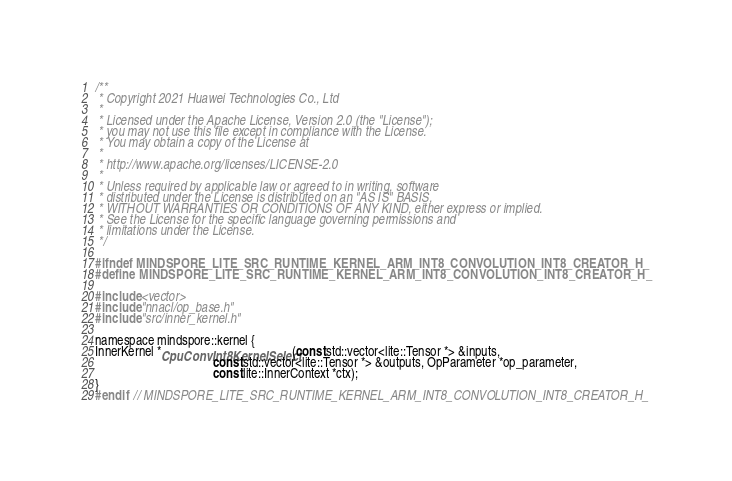Convert code to text. <code><loc_0><loc_0><loc_500><loc_500><_C_>/**
 * Copyright 2021 Huawei Technologies Co., Ltd
 *
 * Licensed under the Apache License, Version 2.0 (the "License");
 * you may not use this file except in compliance with the License.
 * You may obtain a copy of the License at
 *
 * http://www.apache.org/licenses/LICENSE-2.0
 *
 * Unless required by applicable law or agreed to in writing, software
 * distributed under the License is distributed on an "AS IS" BASIS,
 * WITHOUT WARRANTIES OR CONDITIONS OF ANY KIND, either express or implied.
 * See the License for the specific language governing permissions and
 * limitations under the License.
 */

#ifndef MINDSPORE_LITE_SRC_RUNTIME_KERNEL_ARM_INT8_CONVOLUTION_INT8_CREATOR_H_
#define MINDSPORE_LITE_SRC_RUNTIME_KERNEL_ARM_INT8_CONVOLUTION_INT8_CREATOR_H_

#include <vector>
#include "nnacl/op_base.h"
#include "src/inner_kernel.h"

namespace mindspore::kernel {
InnerKernel *CpuConvInt8KernelSelect(const std::vector<lite::Tensor *> &inputs,
                                     const std::vector<lite::Tensor *> &outputs, OpParameter *op_parameter,
                                     const lite::InnerContext *ctx);
}
#endif  // MINDSPORE_LITE_SRC_RUNTIME_KERNEL_ARM_INT8_CONVOLUTION_INT8_CREATOR_H_
</code> 